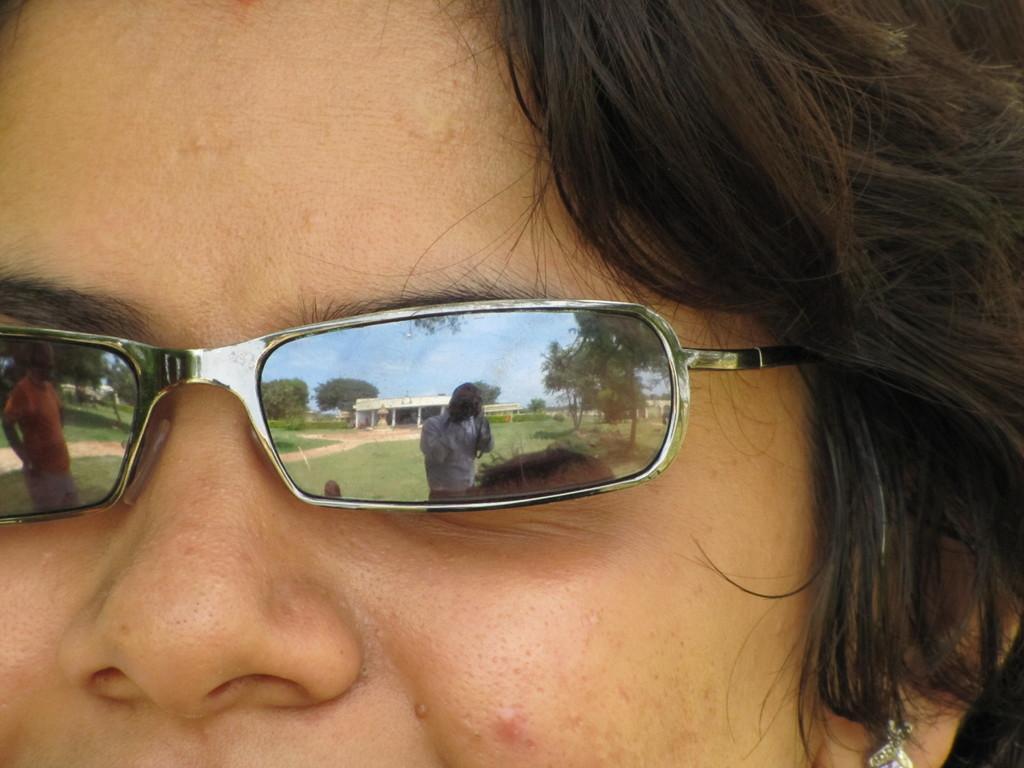Please provide a concise description of this image. In this image I can see the person's face and the person is wearing the goggles. In the goggles I can see the reflection of the other person, few trees in green color and the sky is in blue color. 